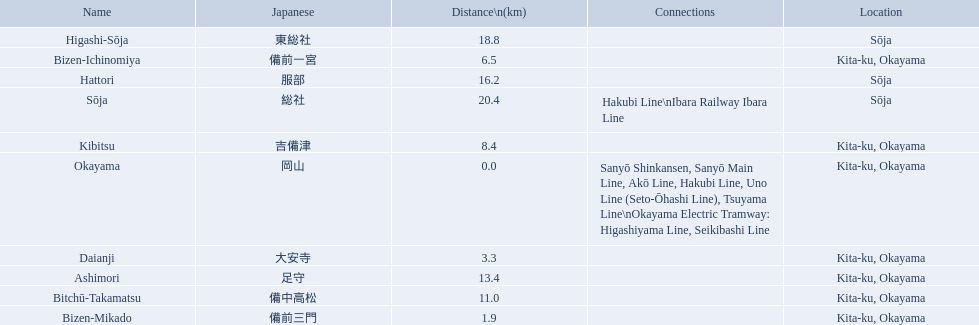What are all the stations on the kibi line? Okayama, Bizen-Mikado, Daianji, Bizen-Ichinomiya, Kibitsu, Bitchū-Takamatsu, Ashimori, Hattori, Higashi-Sōja, Sōja. What are the distances of these stations from the start of the line? 0.0, 1.9, 3.3, 6.5, 8.4, 11.0, 13.4, 16.2, 18.8, 20.4. Of these, which is larger than 1 km? 1.9, 3.3, 6.5, 8.4, 11.0, 13.4, 16.2, 18.8, 20.4. Of these, which is smaller than 2 km? 1.9. Which station is this distance from the start of the line? Bizen-Mikado. 